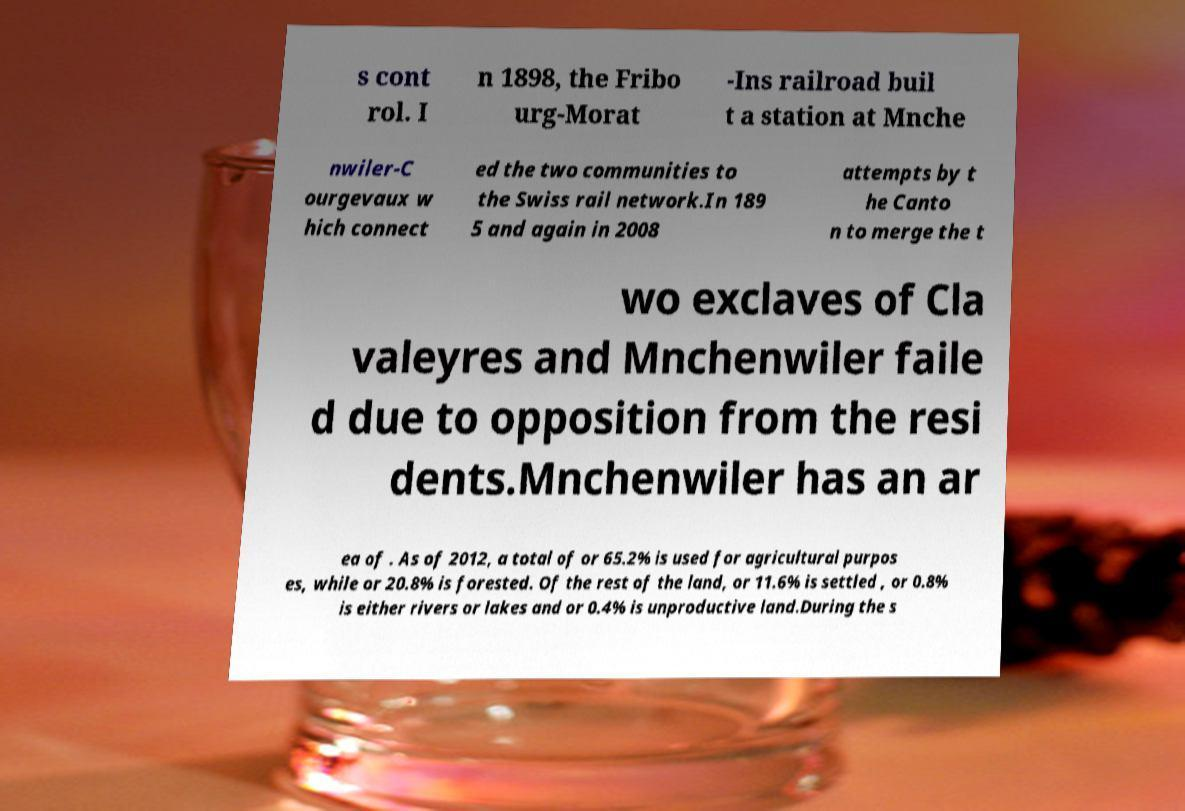I need the written content from this picture converted into text. Can you do that? s cont rol. I n 1898, the Fribo urg-Morat -Ins railroad buil t a station at Mnche nwiler-C ourgevaux w hich connect ed the two communities to the Swiss rail network.In 189 5 and again in 2008 attempts by t he Canto n to merge the t wo exclaves of Cla valeyres and Mnchenwiler faile d due to opposition from the resi dents.Mnchenwiler has an ar ea of . As of 2012, a total of or 65.2% is used for agricultural purpos es, while or 20.8% is forested. Of the rest of the land, or 11.6% is settled , or 0.8% is either rivers or lakes and or 0.4% is unproductive land.During the s 